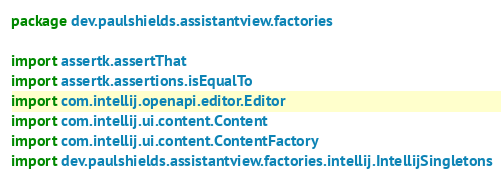<code> <loc_0><loc_0><loc_500><loc_500><_Kotlin_>package dev.paulshields.assistantview.factories

import assertk.assertThat
import assertk.assertions.isEqualTo
import com.intellij.openapi.editor.Editor
import com.intellij.ui.content.Content
import com.intellij.ui.content.ContentFactory
import dev.paulshields.assistantview.factories.intellij.IntellijSingletons</code> 